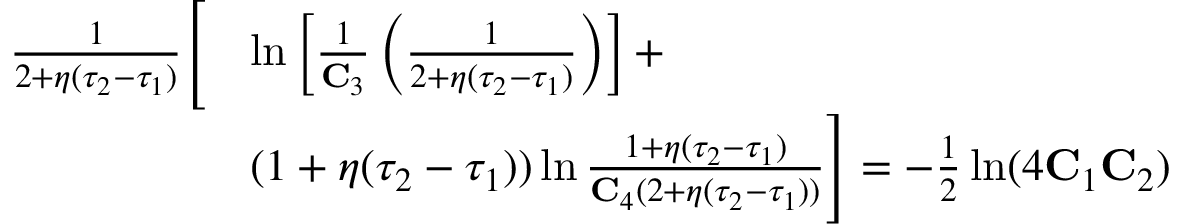Convert formula to latex. <formula><loc_0><loc_0><loc_500><loc_500>\begin{array} { r l } { \frac { 1 } { 2 + \eta ( \tau _ { 2 } - \tau _ { 1 } ) } \left [ } & { \ln \left [ \frac { 1 } { C _ { 3 } } \left ( \frac { 1 } { 2 + \eta ( \tau _ { 2 } - \tau _ { 1 } ) } \right ) \right ] + } \\ & { ( 1 + \eta ( \tau _ { 2 } - \tau _ { 1 } ) ) \ln \frac { 1 + \eta ( \tau _ { 2 } - \tau _ { 1 } ) } { C _ { 4 } ( 2 + \eta ( \tau _ { 2 } - \tau _ { 1 } ) ) } \right ] = - \frac { 1 } { 2 } \ln ( 4 C _ { 1 } C _ { 2 } ) } \end{array}</formula> 